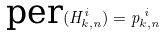Convert formula to latex. <formula><loc_0><loc_0><loc_500><loc_500>\text {per} ( H _ { k , n } ^ { i } ) = p _ { k , n } ^ { \text { } i }</formula> 